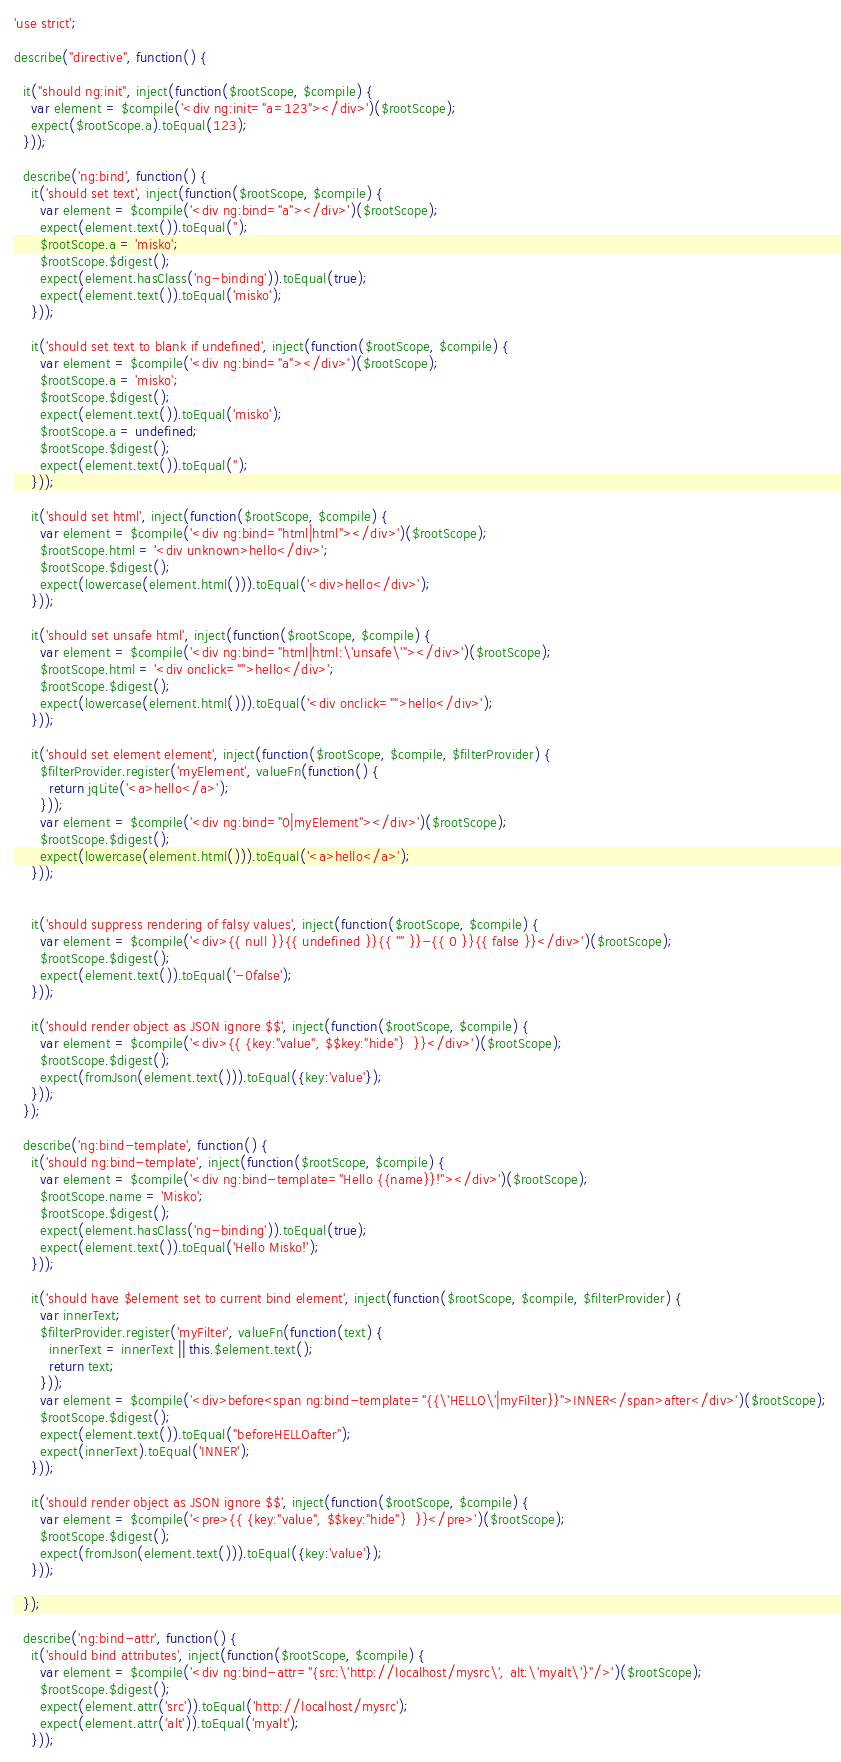Convert code to text. <code><loc_0><loc_0><loc_500><loc_500><_JavaScript_>'use strict';

describe("directive", function() {

  it("should ng:init", inject(function($rootScope, $compile) {
    var element = $compile('<div ng:init="a=123"></div>')($rootScope);
    expect($rootScope.a).toEqual(123);
  }));

  describe('ng:bind', function() {
    it('should set text', inject(function($rootScope, $compile) {
      var element = $compile('<div ng:bind="a"></div>')($rootScope);
      expect(element.text()).toEqual('');
      $rootScope.a = 'misko';
      $rootScope.$digest();
      expect(element.hasClass('ng-binding')).toEqual(true);
      expect(element.text()).toEqual('misko');
    }));

    it('should set text to blank if undefined', inject(function($rootScope, $compile) {
      var element = $compile('<div ng:bind="a"></div>')($rootScope);
      $rootScope.a = 'misko';
      $rootScope.$digest();
      expect(element.text()).toEqual('misko');
      $rootScope.a = undefined;
      $rootScope.$digest();
      expect(element.text()).toEqual('');
    }));

    it('should set html', inject(function($rootScope, $compile) {
      var element = $compile('<div ng:bind="html|html"></div>')($rootScope);
      $rootScope.html = '<div unknown>hello</div>';
      $rootScope.$digest();
      expect(lowercase(element.html())).toEqual('<div>hello</div>');
    }));

    it('should set unsafe html', inject(function($rootScope, $compile) {
      var element = $compile('<div ng:bind="html|html:\'unsafe\'"></div>')($rootScope);
      $rootScope.html = '<div onclick="">hello</div>';
      $rootScope.$digest();
      expect(lowercase(element.html())).toEqual('<div onclick="">hello</div>');
    }));

    it('should set element element', inject(function($rootScope, $compile, $filterProvider) {
      $filterProvider.register('myElement', valueFn(function() {
        return jqLite('<a>hello</a>');
      }));
      var element = $compile('<div ng:bind="0|myElement"></div>')($rootScope);
      $rootScope.$digest();
      expect(lowercase(element.html())).toEqual('<a>hello</a>');
    }));


    it('should suppress rendering of falsy values', inject(function($rootScope, $compile) {
      var element = $compile('<div>{{ null }}{{ undefined }}{{ "" }}-{{ 0 }}{{ false }}</div>')($rootScope);
      $rootScope.$digest();
      expect(element.text()).toEqual('-0false');
    }));

    it('should render object as JSON ignore $$', inject(function($rootScope, $compile) {
      var element = $compile('<div>{{ {key:"value", $$key:"hide"}  }}</div>')($rootScope);
      $rootScope.$digest();
      expect(fromJson(element.text())).toEqual({key:'value'});
    }));
  });

  describe('ng:bind-template', function() {
    it('should ng:bind-template', inject(function($rootScope, $compile) {
      var element = $compile('<div ng:bind-template="Hello {{name}}!"></div>')($rootScope);
      $rootScope.name = 'Misko';
      $rootScope.$digest();
      expect(element.hasClass('ng-binding')).toEqual(true);
      expect(element.text()).toEqual('Hello Misko!');
    }));

    it('should have $element set to current bind element', inject(function($rootScope, $compile, $filterProvider) {
      var innerText;
      $filterProvider.register('myFilter', valueFn(function(text) {
        innerText = innerText || this.$element.text();
        return text;
      }));
      var element = $compile('<div>before<span ng:bind-template="{{\'HELLO\'|myFilter}}">INNER</span>after</div>')($rootScope);
      $rootScope.$digest();
      expect(element.text()).toEqual("beforeHELLOafter");
      expect(innerText).toEqual('INNER');
    }));

    it('should render object as JSON ignore $$', inject(function($rootScope, $compile) {
      var element = $compile('<pre>{{ {key:"value", $$key:"hide"}  }}</pre>')($rootScope);
      $rootScope.$digest();
      expect(fromJson(element.text())).toEqual({key:'value'});
    }));

  });

  describe('ng:bind-attr', function() {
    it('should bind attributes', inject(function($rootScope, $compile) {
      var element = $compile('<div ng:bind-attr="{src:\'http://localhost/mysrc\', alt:\'myalt\'}"/>')($rootScope);
      $rootScope.$digest();
      expect(element.attr('src')).toEqual('http://localhost/mysrc');
      expect(element.attr('alt')).toEqual('myalt');
    }));
</code> 